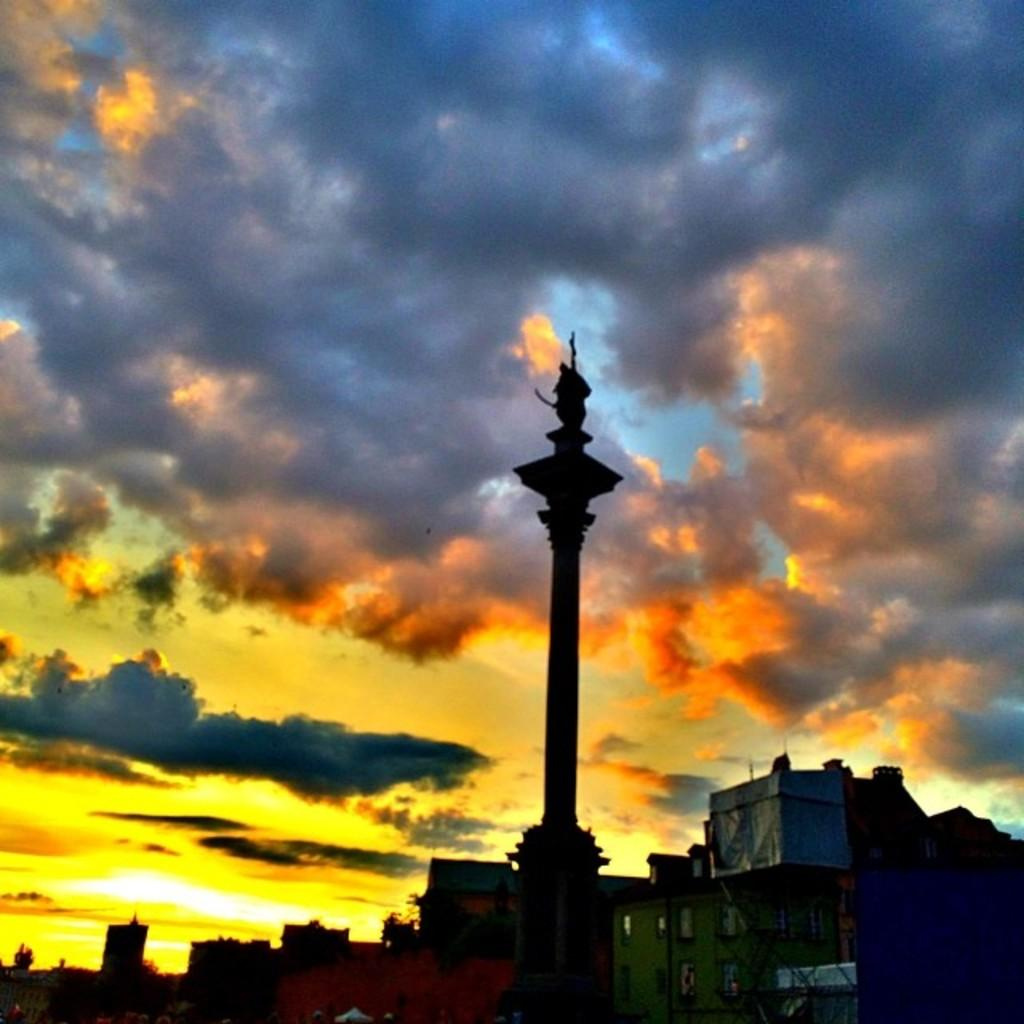What is the main object in the image? There is a pole in the image. What else can be seen in the image besides the pole? There are houses in the image. What is visible at the top of the image? The sky is visible at the top of the image. What can be observed in the sky? Clouds are present in the sky. What type of toothpaste is the father using in the image? There is no father or toothpaste present in the image. 